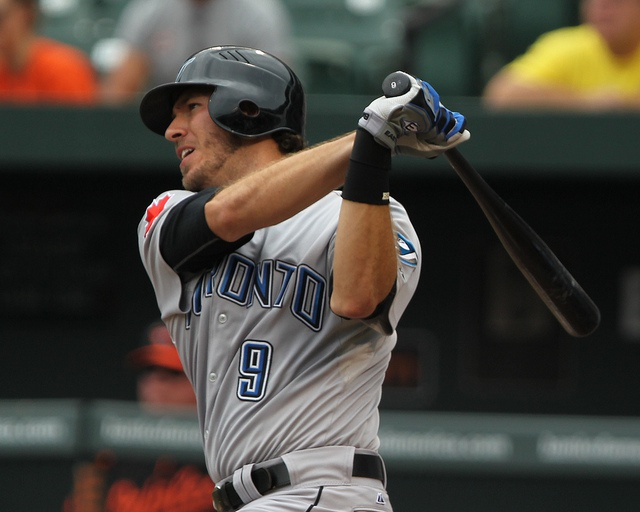Describe the objects in this image and their specific colors. I can see people in gray, black, and darkgray tones, people in gray and darkgray tones, people in gray, gold, khaki, and tan tones, people in gray, black, maroon, and brown tones, and baseball bat in gray, black, and lightgray tones in this image. 